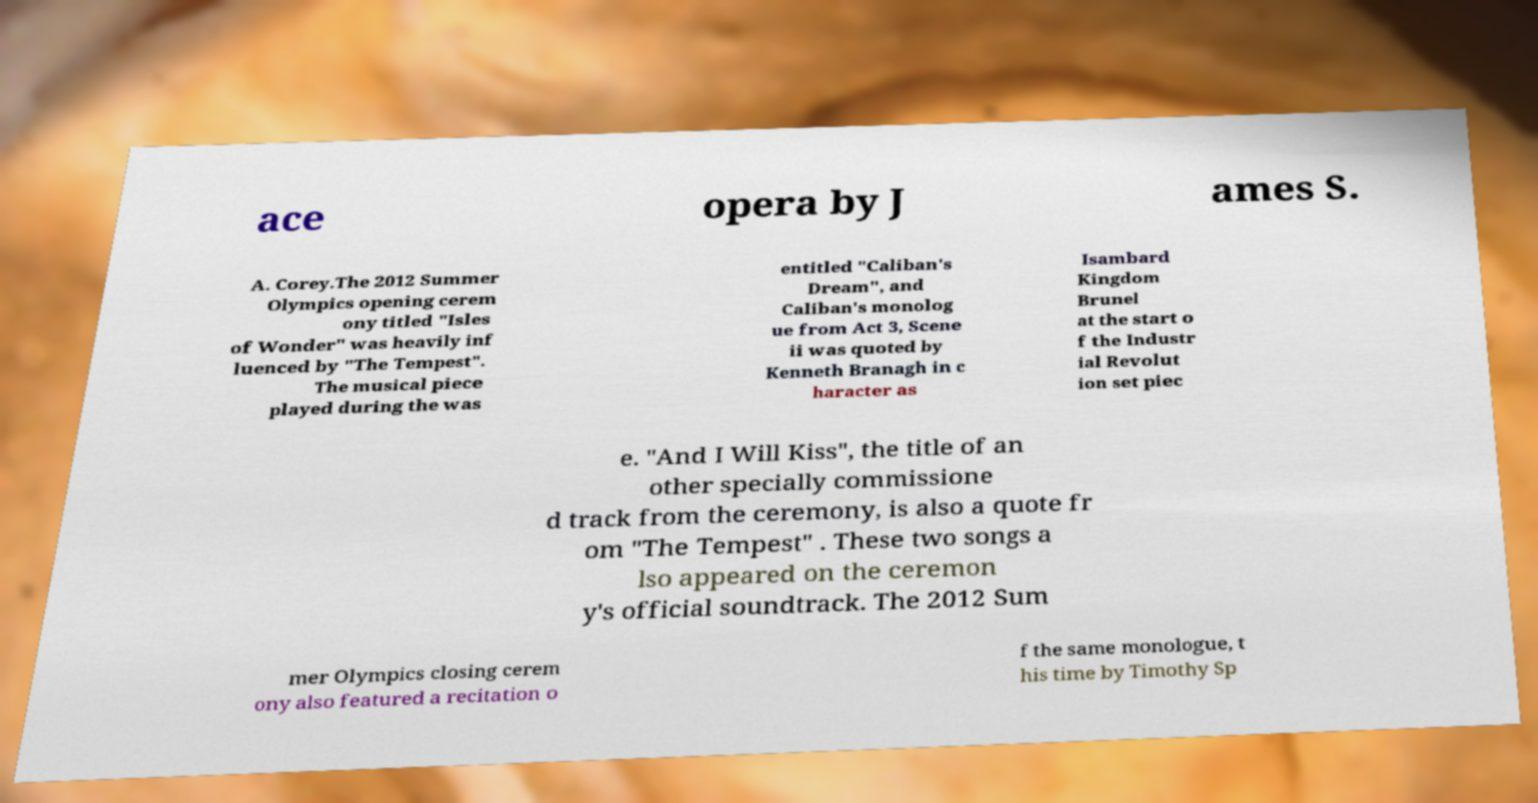Could you assist in decoding the text presented in this image and type it out clearly? ace opera by J ames S. A. Corey.The 2012 Summer Olympics opening cerem ony titled "Isles of Wonder" was heavily inf luenced by "The Tempest". The musical piece played during the was entitled "Caliban's Dream", and Caliban's monolog ue from Act 3, Scene ii was quoted by Kenneth Branagh in c haracter as Isambard Kingdom Brunel at the start o f the Industr ial Revolut ion set piec e. "And I Will Kiss", the title of an other specially commissione d track from the ceremony, is also a quote fr om "The Tempest" . These two songs a lso appeared on the ceremon y's official soundtrack. The 2012 Sum mer Olympics closing cerem ony also featured a recitation o f the same monologue, t his time by Timothy Sp 